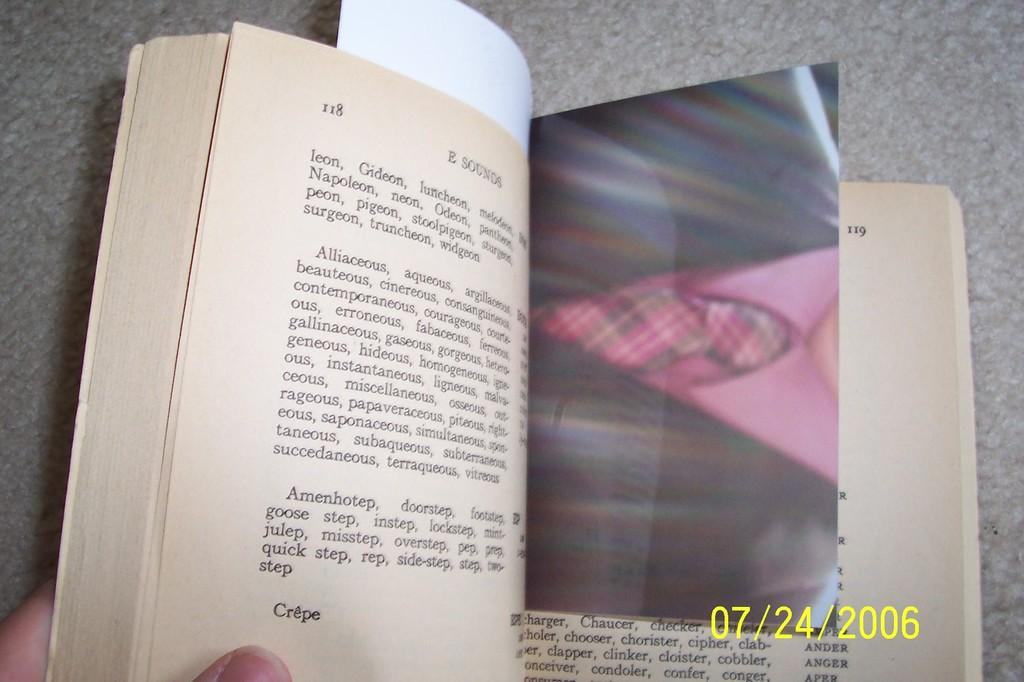<image>
Create a compact narrative representing the image presented. A book titled E Sounds opened to page 118. 